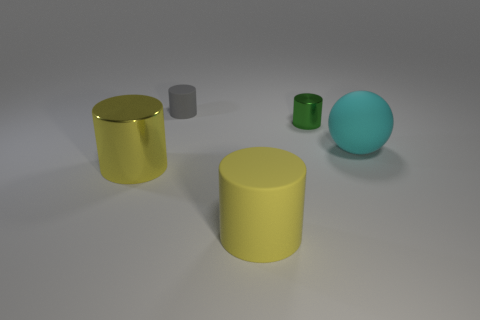Subtract all tiny matte cylinders. How many cylinders are left? 3 Subtract all purple blocks. How many yellow cylinders are left? 2 Add 4 cyan objects. How many objects exist? 9 Subtract all green cylinders. How many cylinders are left? 3 Subtract all balls. How many objects are left? 4 Subtract all green cylinders. Subtract all purple balls. How many cylinders are left? 3 Subtract 1 green cylinders. How many objects are left? 4 Subtract all metal objects. Subtract all large objects. How many objects are left? 0 Add 4 small green shiny objects. How many small green shiny objects are left? 5 Add 5 large brown metallic objects. How many large brown metallic objects exist? 5 